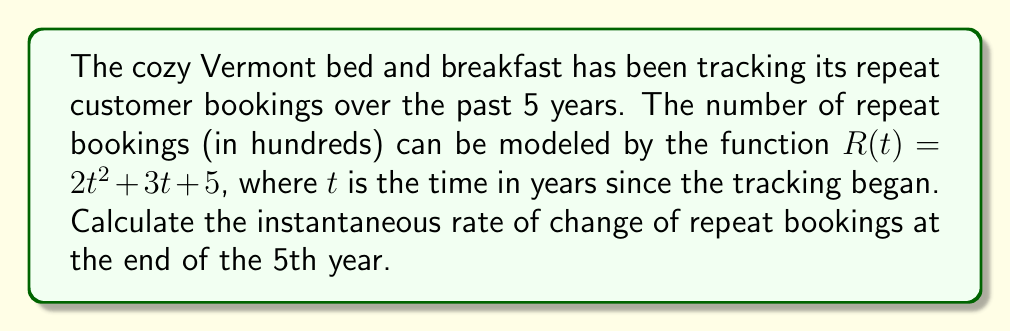What is the answer to this math problem? To find the instantaneous rate of change of repeat bookings at the end of the 5th year, we need to calculate the derivative of the function $R(t)$ and evaluate it at $t = 5$.

1. Given function: $R(t) = 2t^2 + 3t + 5$

2. To find the derivative, we use the power rule and the constant rule:
   $$\frac{dR}{dt} = 4t + 3$$

3. Now, we evaluate the derivative at $t = 5$:
   $$\frac{dR}{dt}\Big|_{t=5} = 4(5) + 3 = 20 + 3 = 23$$

4. Interpret the result:
   The instantaneous rate of change at $t = 5$ is 23 hundred bookings per year, or 2,300 bookings per year.
Answer: The instantaneous rate of change of repeat bookings at the end of the 5th year is 2,300 bookings per year. 